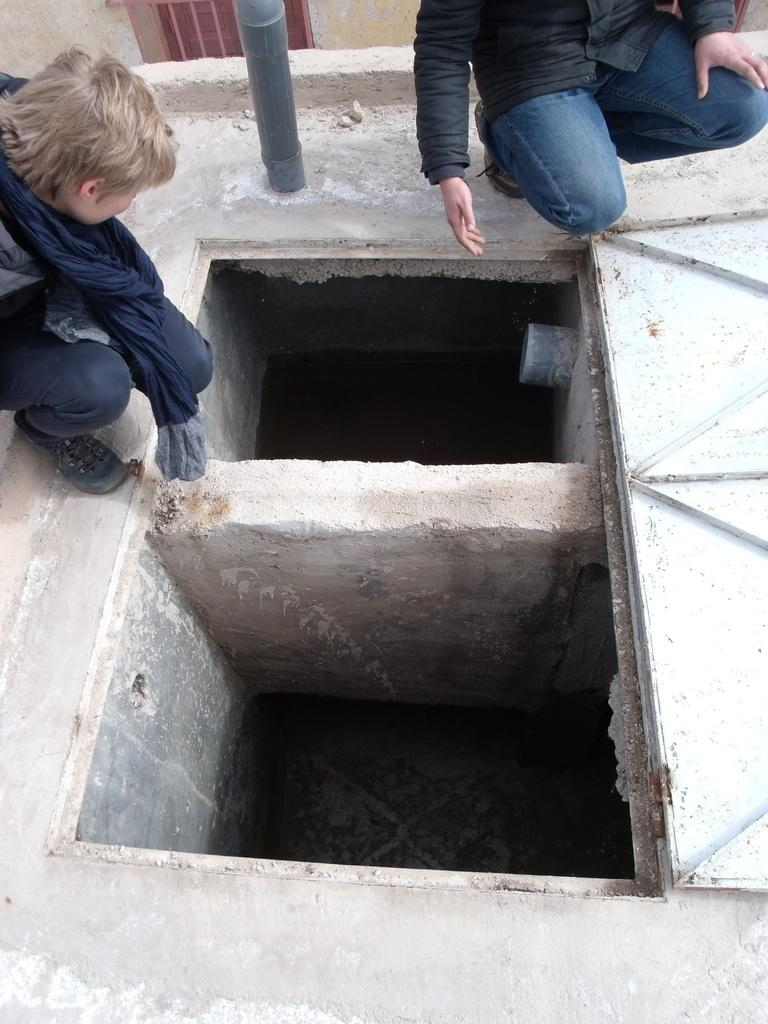What type of pear is being used to play marbles with a cart in the image? There is no pear, marble, or cart present in the image. 